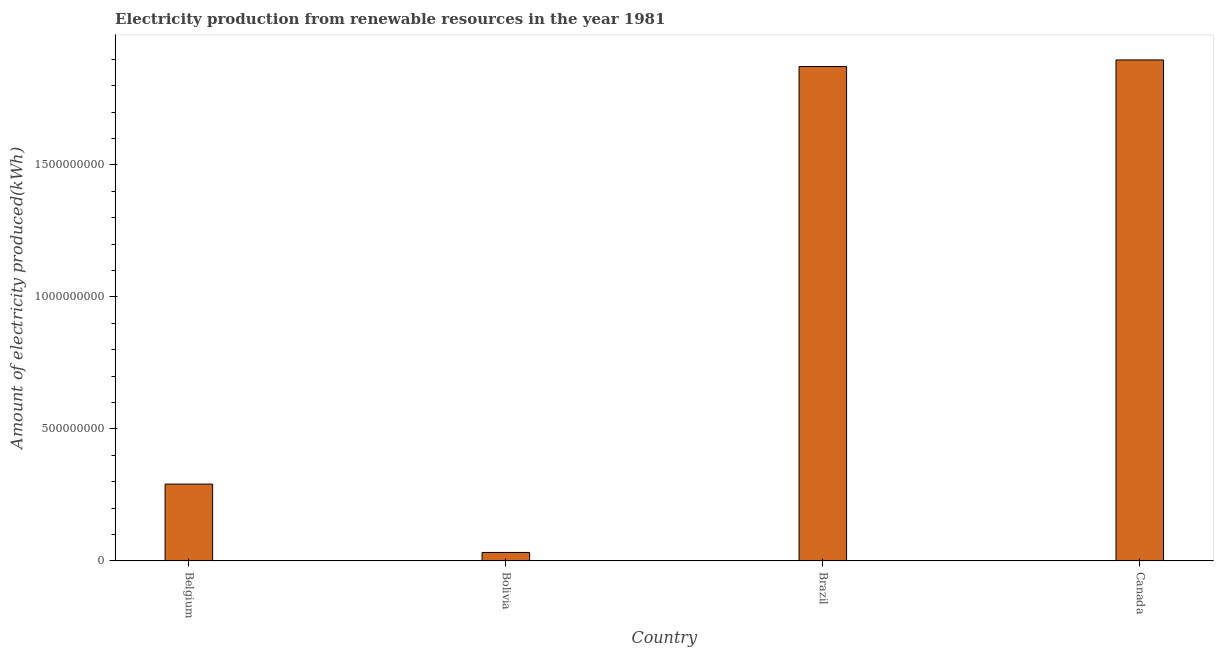Does the graph contain grids?
Your response must be concise. No. What is the title of the graph?
Your answer should be very brief. Electricity production from renewable resources in the year 1981. What is the label or title of the Y-axis?
Ensure brevity in your answer.  Amount of electricity produced(kWh). What is the amount of electricity produced in Bolivia?
Your answer should be very brief. 3.20e+07. Across all countries, what is the maximum amount of electricity produced?
Provide a succinct answer. 1.90e+09. Across all countries, what is the minimum amount of electricity produced?
Your answer should be compact. 3.20e+07. In which country was the amount of electricity produced maximum?
Your answer should be compact. Canada. In which country was the amount of electricity produced minimum?
Provide a short and direct response. Bolivia. What is the sum of the amount of electricity produced?
Your response must be concise. 4.09e+09. What is the difference between the amount of electricity produced in Bolivia and Brazil?
Provide a short and direct response. -1.84e+09. What is the average amount of electricity produced per country?
Your answer should be compact. 1.02e+09. What is the median amount of electricity produced?
Offer a very short reply. 1.08e+09. In how many countries, is the amount of electricity produced greater than 900000000 kWh?
Offer a very short reply. 2. What is the ratio of the amount of electricity produced in Bolivia to that in Brazil?
Your response must be concise. 0.02. Is the amount of electricity produced in Bolivia less than that in Canada?
Provide a succinct answer. Yes. Is the difference between the amount of electricity produced in Bolivia and Canada greater than the difference between any two countries?
Give a very brief answer. Yes. What is the difference between the highest and the second highest amount of electricity produced?
Your response must be concise. 2.50e+07. What is the difference between the highest and the lowest amount of electricity produced?
Make the answer very short. 1.87e+09. Are all the bars in the graph horizontal?
Your answer should be compact. No. How many countries are there in the graph?
Your answer should be very brief. 4. What is the Amount of electricity produced(kWh) of Belgium?
Offer a very short reply. 2.91e+08. What is the Amount of electricity produced(kWh) of Bolivia?
Ensure brevity in your answer.  3.20e+07. What is the Amount of electricity produced(kWh) of Brazil?
Your response must be concise. 1.87e+09. What is the Amount of electricity produced(kWh) of Canada?
Ensure brevity in your answer.  1.90e+09. What is the difference between the Amount of electricity produced(kWh) in Belgium and Bolivia?
Keep it short and to the point. 2.59e+08. What is the difference between the Amount of electricity produced(kWh) in Belgium and Brazil?
Keep it short and to the point. -1.58e+09. What is the difference between the Amount of electricity produced(kWh) in Belgium and Canada?
Provide a short and direct response. -1.61e+09. What is the difference between the Amount of electricity produced(kWh) in Bolivia and Brazil?
Make the answer very short. -1.84e+09. What is the difference between the Amount of electricity produced(kWh) in Bolivia and Canada?
Your response must be concise. -1.87e+09. What is the difference between the Amount of electricity produced(kWh) in Brazil and Canada?
Provide a short and direct response. -2.50e+07. What is the ratio of the Amount of electricity produced(kWh) in Belgium to that in Bolivia?
Your response must be concise. 9.09. What is the ratio of the Amount of electricity produced(kWh) in Belgium to that in Brazil?
Make the answer very short. 0.15. What is the ratio of the Amount of electricity produced(kWh) in Belgium to that in Canada?
Your response must be concise. 0.15. What is the ratio of the Amount of electricity produced(kWh) in Bolivia to that in Brazil?
Make the answer very short. 0.02. What is the ratio of the Amount of electricity produced(kWh) in Bolivia to that in Canada?
Provide a short and direct response. 0.02. What is the ratio of the Amount of electricity produced(kWh) in Brazil to that in Canada?
Provide a short and direct response. 0.99. 